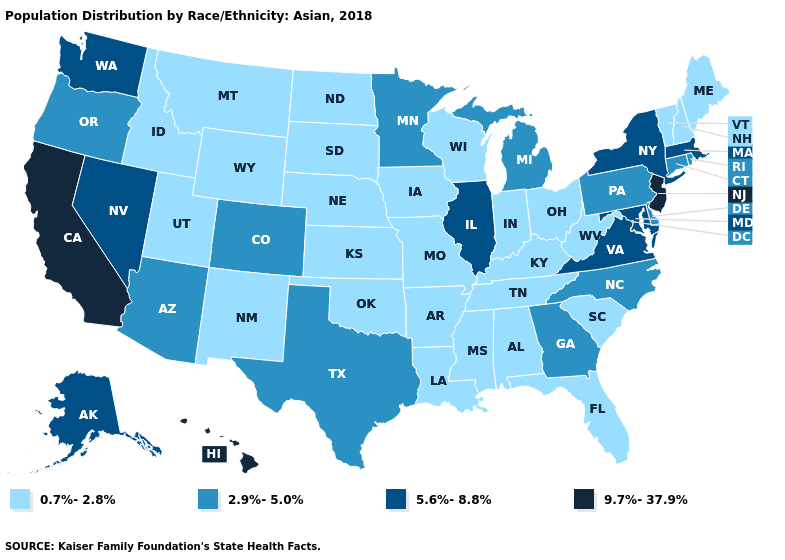Does Missouri have the highest value in the MidWest?
Keep it brief. No. What is the value of Wyoming?
Write a very short answer. 0.7%-2.8%. What is the lowest value in states that border Iowa?
Keep it brief. 0.7%-2.8%. Name the states that have a value in the range 2.9%-5.0%?
Concise answer only. Arizona, Colorado, Connecticut, Delaware, Georgia, Michigan, Minnesota, North Carolina, Oregon, Pennsylvania, Rhode Island, Texas. Name the states that have a value in the range 2.9%-5.0%?
Short answer required. Arizona, Colorado, Connecticut, Delaware, Georgia, Michigan, Minnesota, North Carolina, Oregon, Pennsylvania, Rhode Island, Texas. Name the states that have a value in the range 2.9%-5.0%?
Write a very short answer. Arizona, Colorado, Connecticut, Delaware, Georgia, Michigan, Minnesota, North Carolina, Oregon, Pennsylvania, Rhode Island, Texas. Name the states that have a value in the range 5.6%-8.8%?
Keep it brief. Alaska, Illinois, Maryland, Massachusetts, Nevada, New York, Virginia, Washington. What is the value of Idaho?
Give a very brief answer. 0.7%-2.8%. Name the states that have a value in the range 9.7%-37.9%?
Write a very short answer. California, Hawaii, New Jersey. Among the states that border North Carolina , does Tennessee have the lowest value?
Quick response, please. Yes. Name the states that have a value in the range 2.9%-5.0%?
Give a very brief answer. Arizona, Colorado, Connecticut, Delaware, Georgia, Michigan, Minnesota, North Carolina, Oregon, Pennsylvania, Rhode Island, Texas. Which states hav the highest value in the South?
Concise answer only. Maryland, Virginia. What is the value of Iowa?
Keep it brief. 0.7%-2.8%. Name the states that have a value in the range 5.6%-8.8%?
Quick response, please. Alaska, Illinois, Maryland, Massachusetts, Nevada, New York, Virginia, Washington. 